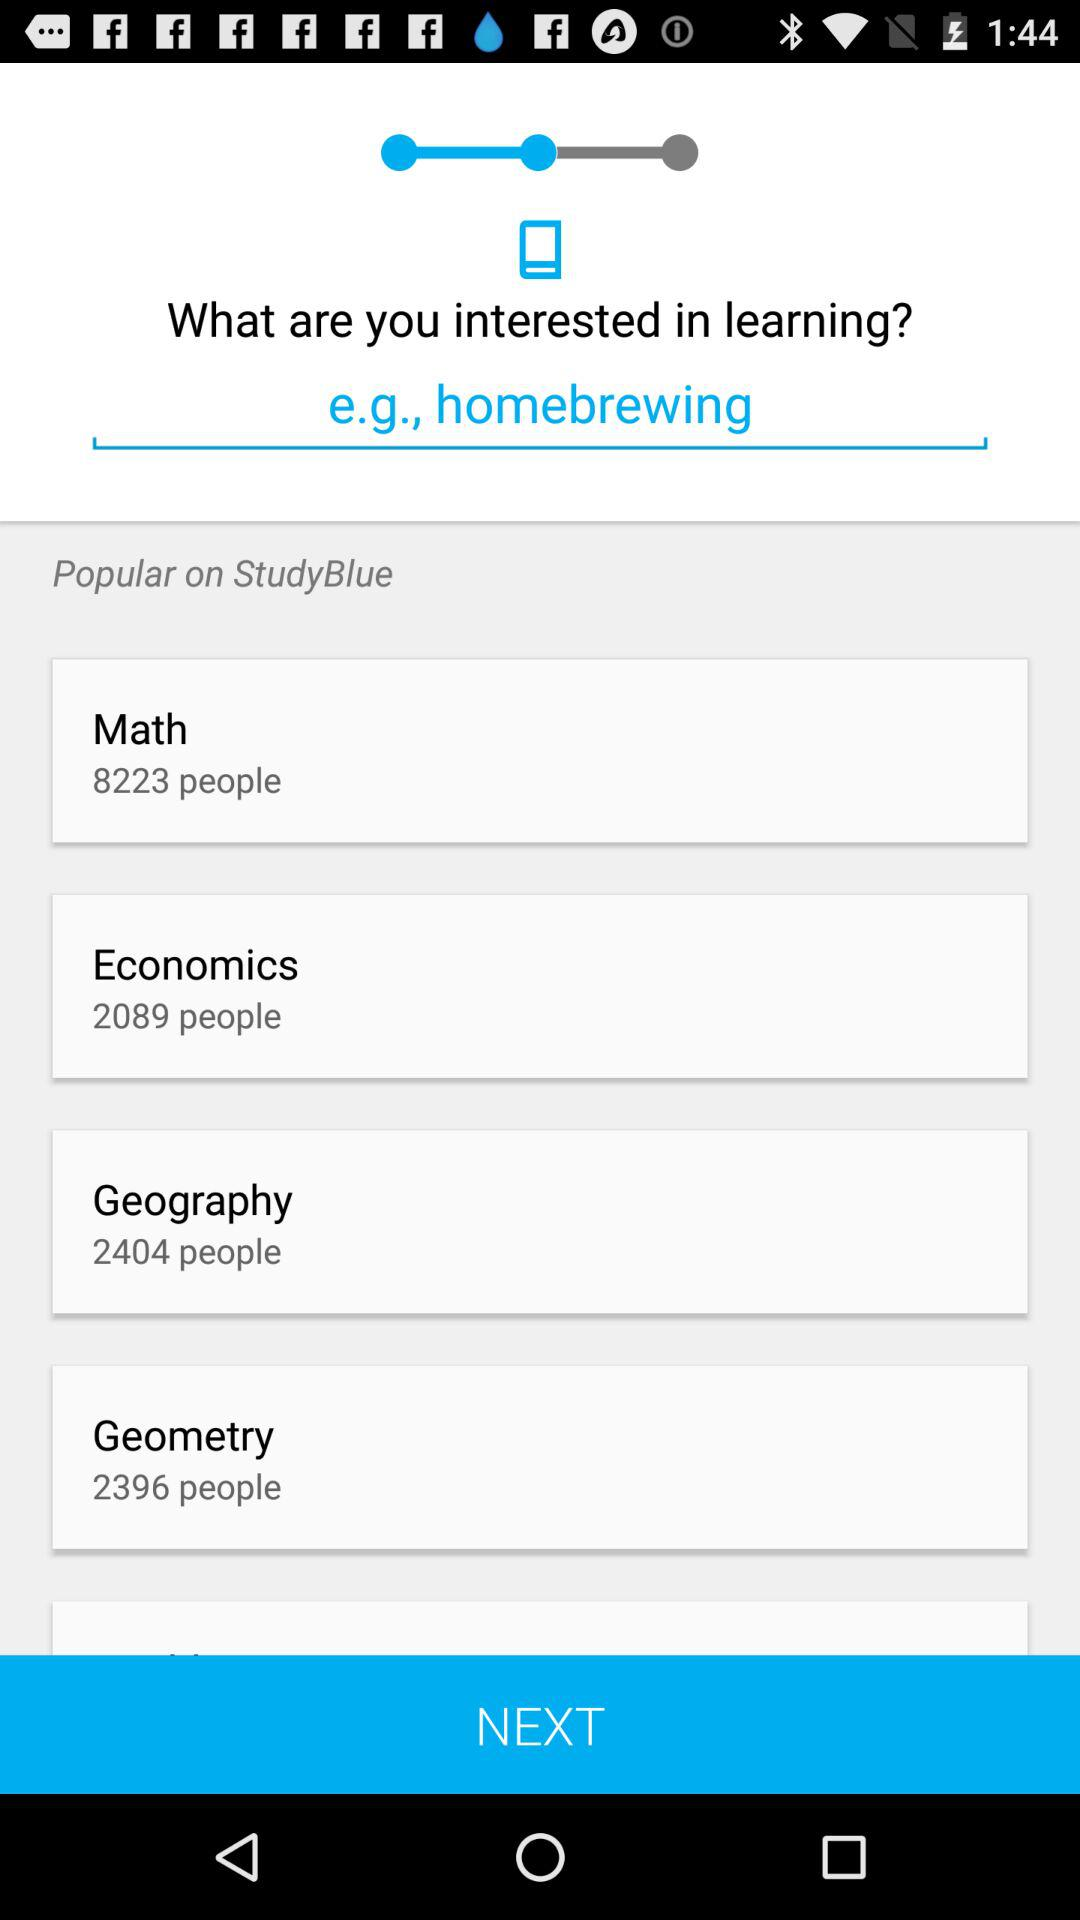Which subjects are popular on "StudyBlue"? The subjects are math, economics, geography, and geometry. 